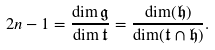<formula> <loc_0><loc_0><loc_500><loc_500>2 n - 1 = \frac { \dim \mathfrak { g } } { \dim \mathfrak { t } } = \frac { \dim ( \mathfrak { h } ) } { \dim ( \mathfrak { t } \cap \mathfrak { h } ) } .</formula> 